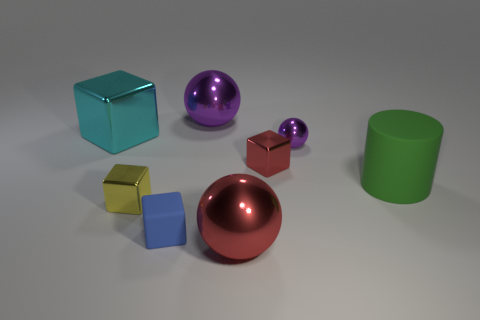What shape is the big object that is the same color as the small metal sphere?
Your response must be concise. Sphere. There is another object that is made of the same material as the large green thing; what shape is it?
Provide a succinct answer. Cube. Does the tiny ball have the same color as the large sphere behind the blue matte thing?
Give a very brief answer. Yes. What material is the purple thing that is to the left of the small purple ball?
Ensure brevity in your answer.  Metal. There is a red metallic block; is it the same size as the purple metal object that is in front of the large purple metal thing?
Offer a terse response. Yes. What shape is the purple metallic thing on the right side of the purple metallic ball that is left of the large ball that is in front of the cylinder?
Ensure brevity in your answer.  Sphere. Is the number of big metal balls less than the number of large things?
Your answer should be very brief. Yes. There is a yellow block; are there any big red things behind it?
Give a very brief answer. No. What shape is the small thing that is right of the yellow shiny cube and left of the small red block?
Provide a succinct answer. Cube. Are there any small metallic things of the same shape as the tiny rubber object?
Offer a very short reply. Yes. 